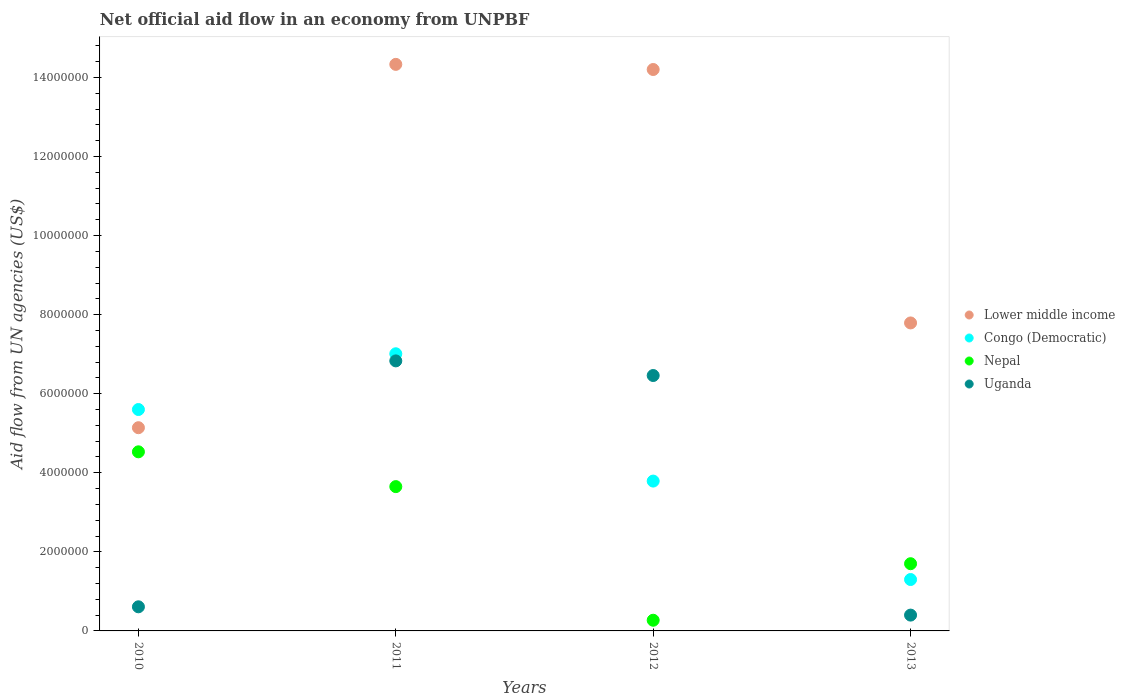Is the number of dotlines equal to the number of legend labels?
Your response must be concise. Yes. What is the net official aid flow in Nepal in 2012?
Provide a succinct answer. 2.70e+05. Across all years, what is the maximum net official aid flow in Congo (Democratic)?
Provide a short and direct response. 7.01e+06. Across all years, what is the minimum net official aid flow in Uganda?
Provide a succinct answer. 4.00e+05. In which year was the net official aid flow in Uganda maximum?
Your response must be concise. 2011. In which year was the net official aid flow in Congo (Democratic) minimum?
Make the answer very short. 2013. What is the total net official aid flow in Nepal in the graph?
Make the answer very short. 1.02e+07. What is the difference between the net official aid flow in Lower middle income in 2012 and that in 2013?
Your response must be concise. 6.41e+06. What is the difference between the net official aid flow in Nepal in 2011 and the net official aid flow in Uganda in 2010?
Offer a very short reply. 3.04e+06. What is the average net official aid flow in Congo (Democratic) per year?
Offer a terse response. 4.42e+06. In the year 2011, what is the difference between the net official aid flow in Congo (Democratic) and net official aid flow in Nepal?
Your answer should be compact. 3.36e+06. What is the ratio of the net official aid flow in Congo (Democratic) in 2010 to that in 2012?
Keep it short and to the point. 1.48. Is the net official aid flow in Lower middle income in 2011 less than that in 2013?
Your answer should be very brief. No. Is the difference between the net official aid flow in Congo (Democratic) in 2010 and 2013 greater than the difference between the net official aid flow in Nepal in 2010 and 2013?
Provide a short and direct response. Yes. What is the difference between the highest and the second highest net official aid flow in Uganda?
Offer a terse response. 3.70e+05. What is the difference between the highest and the lowest net official aid flow in Congo (Democratic)?
Provide a short and direct response. 5.71e+06. Is the net official aid flow in Nepal strictly less than the net official aid flow in Uganda over the years?
Ensure brevity in your answer.  No. How many dotlines are there?
Give a very brief answer. 4. Are the values on the major ticks of Y-axis written in scientific E-notation?
Your answer should be very brief. No. Does the graph contain grids?
Offer a very short reply. No. How are the legend labels stacked?
Make the answer very short. Vertical. What is the title of the graph?
Provide a short and direct response. Net official aid flow in an economy from UNPBF. What is the label or title of the Y-axis?
Ensure brevity in your answer.  Aid flow from UN agencies (US$). What is the Aid flow from UN agencies (US$) of Lower middle income in 2010?
Offer a terse response. 5.14e+06. What is the Aid flow from UN agencies (US$) in Congo (Democratic) in 2010?
Keep it short and to the point. 5.60e+06. What is the Aid flow from UN agencies (US$) in Nepal in 2010?
Your response must be concise. 4.53e+06. What is the Aid flow from UN agencies (US$) of Uganda in 2010?
Provide a short and direct response. 6.10e+05. What is the Aid flow from UN agencies (US$) in Lower middle income in 2011?
Your answer should be very brief. 1.43e+07. What is the Aid flow from UN agencies (US$) in Congo (Democratic) in 2011?
Offer a very short reply. 7.01e+06. What is the Aid flow from UN agencies (US$) in Nepal in 2011?
Ensure brevity in your answer.  3.65e+06. What is the Aid flow from UN agencies (US$) of Uganda in 2011?
Give a very brief answer. 6.83e+06. What is the Aid flow from UN agencies (US$) of Lower middle income in 2012?
Provide a succinct answer. 1.42e+07. What is the Aid flow from UN agencies (US$) in Congo (Democratic) in 2012?
Your answer should be very brief. 3.79e+06. What is the Aid flow from UN agencies (US$) of Uganda in 2012?
Ensure brevity in your answer.  6.46e+06. What is the Aid flow from UN agencies (US$) in Lower middle income in 2013?
Your answer should be very brief. 7.79e+06. What is the Aid flow from UN agencies (US$) of Congo (Democratic) in 2013?
Make the answer very short. 1.30e+06. What is the Aid flow from UN agencies (US$) of Nepal in 2013?
Your response must be concise. 1.70e+06. What is the Aid flow from UN agencies (US$) in Uganda in 2013?
Your answer should be compact. 4.00e+05. Across all years, what is the maximum Aid flow from UN agencies (US$) in Lower middle income?
Provide a short and direct response. 1.43e+07. Across all years, what is the maximum Aid flow from UN agencies (US$) of Congo (Democratic)?
Ensure brevity in your answer.  7.01e+06. Across all years, what is the maximum Aid flow from UN agencies (US$) of Nepal?
Provide a succinct answer. 4.53e+06. Across all years, what is the maximum Aid flow from UN agencies (US$) in Uganda?
Offer a terse response. 6.83e+06. Across all years, what is the minimum Aid flow from UN agencies (US$) of Lower middle income?
Your answer should be very brief. 5.14e+06. Across all years, what is the minimum Aid flow from UN agencies (US$) of Congo (Democratic)?
Your answer should be very brief. 1.30e+06. What is the total Aid flow from UN agencies (US$) in Lower middle income in the graph?
Offer a terse response. 4.15e+07. What is the total Aid flow from UN agencies (US$) of Congo (Democratic) in the graph?
Your answer should be very brief. 1.77e+07. What is the total Aid flow from UN agencies (US$) in Nepal in the graph?
Provide a short and direct response. 1.02e+07. What is the total Aid flow from UN agencies (US$) in Uganda in the graph?
Your answer should be compact. 1.43e+07. What is the difference between the Aid flow from UN agencies (US$) in Lower middle income in 2010 and that in 2011?
Ensure brevity in your answer.  -9.19e+06. What is the difference between the Aid flow from UN agencies (US$) in Congo (Democratic) in 2010 and that in 2011?
Offer a terse response. -1.41e+06. What is the difference between the Aid flow from UN agencies (US$) of Nepal in 2010 and that in 2011?
Ensure brevity in your answer.  8.80e+05. What is the difference between the Aid flow from UN agencies (US$) in Uganda in 2010 and that in 2011?
Offer a very short reply. -6.22e+06. What is the difference between the Aid flow from UN agencies (US$) in Lower middle income in 2010 and that in 2012?
Your response must be concise. -9.06e+06. What is the difference between the Aid flow from UN agencies (US$) of Congo (Democratic) in 2010 and that in 2012?
Your response must be concise. 1.81e+06. What is the difference between the Aid flow from UN agencies (US$) of Nepal in 2010 and that in 2012?
Keep it short and to the point. 4.26e+06. What is the difference between the Aid flow from UN agencies (US$) in Uganda in 2010 and that in 2012?
Make the answer very short. -5.85e+06. What is the difference between the Aid flow from UN agencies (US$) in Lower middle income in 2010 and that in 2013?
Offer a terse response. -2.65e+06. What is the difference between the Aid flow from UN agencies (US$) of Congo (Democratic) in 2010 and that in 2013?
Your answer should be very brief. 4.30e+06. What is the difference between the Aid flow from UN agencies (US$) in Nepal in 2010 and that in 2013?
Offer a terse response. 2.83e+06. What is the difference between the Aid flow from UN agencies (US$) of Lower middle income in 2011 and that in 2012?
Offer a terse response. 1.30e+05. What is the difference between the Aid flow from UN agencies (US$) in Congo (Democratic) in 2011 and that in 2012?
Give a very brief answer. 3.22e+06. What is the difference between the Aid flow from UN agencies (US$) of Nepal in 2011 and that in 2012?
Your answer should be very brief. 3.38e+06. What is the difference between the Aid flow from UN agencies (US$) in Lower middle income in 2011 and that in 2013?
Offer a very short reply. 6.54e+06. What is the difference between the Aid flow from UN agencies (US$) in Congo (Democratic) in 2011 and that in 2013?
Make the answer very short. 5.71e+06. What is the difference between the Aid flow from UN agencies (US$) of Nepal in 2011 and that in 2013?
Provide a short and direct response. 1.95e+06. What is the difference between the Aid flow from UN agencies (US$) in Uganda in 2011 and that in 2013?
Your answer should be very brief. 6.43e+06. What is the difference between the Aid flow from UN agencies (US$) of Lower middle income in 2012 and that in 2013?
Offer a terse response. 6.41e+06. What is the difference between the Aid flow from UN agencies (US$) in Congo (Democratic) in 2012 and that in 2013?
Keep it short and to the point. 2.49e+06. What is the difference between the Aid flow from UN agencies (US$) in Nepal in 2012 and that in 2013?
Offer a very short reply. -1.43e+06. What is the difference between the Aid flow from UN agencies (US$) of Uganda in 2012 and that in 2013?
Your response must be concise. 6.06e+06. What is the difference between the Aid flow from UN agencies (US$) of Lower middle income in 2010 and the Aid flow from UN agencies (US$) of Congo (Democratic) in 2011?
Keep it short and to the point. -1.87e+06. What is the difference between the Aid flow from UN agencies (US$) of Lower middle income in 2010 and the Aid flow from UN agencies (US$) of Nepal in 2011?
Keep it short and to the point. 1.49e+06. What is the difference between the Aid flow from UN agencies (US$) in Lower middle income in 2010 and the Aid flow from UN agencies (US$) in Uganda in 2011?
Your answer should be very brief. -1.69e+06. What is the difference between the Aid flow from UN agencies (US$) of Congo (Democratic) in 2010 and the Aid flow from UN agencies (US$) of Nepal in 2011?
Keep it short and to the point. 1.95e+06. What is the difference between the Aid flow from UN agencies (US$) of Congo (Democratic) in 2010 and the Aid flow from UN agencies (US$) of Uganda in 2011?
Provide a short and direct response. -1.23e+06. What is the difference between the Aid flow from UN agencies (US$) in Nepal in 2010 and the Aid flow from UN agencies (US$) in Uganda in 2011?
Provide a short and direct response. -2.30e+06. What is the difference between the Aid flow from UN agencies (US$) in Lower middle income in 2010 and the Aid flow from UN agencies (US$) in Congo (Democratic) in 2012?
Offer a very short reply. 1.35e+06. What is the difference between the Aid flow from UN agencies (US$) in Lower middle income in 2010 and the Aid flow from UN agencies (US$) in Nepal in 2012?
Provide a short and direct response. 4.87e+06. What is the difference between the Aid flow from UN agencies (US$) of Lower middle income in 2010 and the Aid flow from UN agencies (US$) of Uganda in 2012?
Give a very brief answer. -1.32e+06. What is the difference between the Aid flow from UN agencies (US$) of Congo (Democratic) in 2010 and the Aid flow from UN agencies (US$) of Nepal in 2012?
Ensure brevity in your answer.  5.33e+06. What is the difference between the Aid flow from UN agencies (US$) in Congo (Democratic) in 2010 and the Aid flow from UN agencies (US$) in Uganda in 2012?
Ensure brevity in your answer.  -8.60e+05. What is the difference between the Aid flow from UN agencies (US$) in Nepal in 2010 and the Aid flow from UN agencies (US$) in Uganda in 2012?
Offer a terse response. -1.93e+06. What is the difference between the Aid flow from UN agencies (US$) of Lower middle income in 2010 and the Aid flow from UN agencies (US$) of Congo (Democratic) in 2013?
Your response must be concise. 3.84e+06. What is the difference between the Aid flow from UN agencies (US$) of Lower middle income in 2010 and the Aid flow from UN agencies (US$) of Nepal in 2013?
Provide a succinct answer. 3.44e+06. What is the difference between the Aid flow from UN agencies (US$) in Lower middle income in 2010 and the Aid flow from UN agencies (US$) in Uganda in 2013?
Your answer should be compact. 4.74e+06. What is the difference between the Aid flow from UN agencies (US$) in Congo (Democratic) in 2010 and the Aid flow from UN agencies (US$) in Nepal in 2013?
Offer a terse response. 3.90e+06. What is the difference between the Aid flow from UN agencies (US$) of Congo (Democratic) in 2010 and the Aid flow from UN agencies (US$) of Uganda in 2013?
Offer a very short reply. 5.20e+06. What is the difference between the Aid flow from UN agencies (US$) in Nepal in 2010 and the Aid flow from UN agencies (US$) in Uganda in 2013?
Offer a terse response. 4.13e+06. What is the difference between the Aid flow from UN agencies (US$) of Lower middle income in 2011 and the Aid flow from UN agencies (US$) of Congo (Democratic) in 2012?
Offer a terse response. 1.05e+07. What is the difference between the Aid flow from UN agencies (US$) of Lower middle income in 2011 and the Aid flow from UN agencies (US$) of Nepal in 2012?
Your response must be concise. 1.41e+07. What is the difference between the Aid flow from UN agencies (US$) of Lower middle income in 2011 and the Aid flow from UN agencies (US$) of Uganda in 2012?
Offer a very short reply. 7.87e+06. What is the difference between the Aid flow from UN agencies (US$) in Congo (Democratic) in 2011 and the Aid flow from UN agencies (US$) in Nepal in 2012?
Offer a very short reply. 6.74e+06. What is the difference between the Aid flow from UN agencies (US$) of Congo (Democratic) in 2011 and the Aid flow from UN agencies (US$) of Uganda in 2012?
Ensure brevity in your answer.  5.50e+05. What is the difference between the Aid flow from UN agencies (US$) of Nepal in 2011 and the Aid flow from UN agencies (US$) of Uganda in 2012?
Provide a succinct answer. -2.81e+06. What is the difference between the Aid flow from UN agencies (US$) of Lower middle income in 2011 and the Aid flow from UN agencies (US$) of Congo (Democratic) in 2013?
Ensure brevity in your answer.  1.30e+07. What is the difference between the Aid flow from UN agencies (US$) of Lower middle income in 2011 and the Aid flow from UN agencies (US$) of Nepal in 2013?
Your answer should be compact. 1.26e+07. What is the difference between the Aid flow from UN agencies (US$) of Lower middle income in 2011 and the Aid flow from UN agencies (US$) of Uganda in 2013?
Your response must be concise. 1.39e+07. What is the difference between the Aid flow from UN agencies (US$) in Congo (Democratic) in 2011 and the Aid flow from UN agencies (US$) in Nepal in 2013?
Offer a terse response. 5.31e+06. What is the difference between the Aid flow from UN agencies (US$) in Congo (Democratic) in 2011 and the Aid flow from UN agencies (US$) in Uganda in 2013?
Provide a short and direct response. 6.61e+06. What is the difference between the Aid flow from UN agencies (US$) of Nepal in 2011 and the Aid flow from UN agencies (US$) of Uganda in 2013?
Offer a terse response. 3.25e+06. What is the difference between the Aid flow from UN agencies (US$) in Lower middle income in 2012 and the Aid flow from UN agencies (US$) in Congo (Democratic) in 2013?
Your answer should be compact. 1.29e+07. What is the difference between the Aid flow from UN agencies (US$) of Lower middle income in 2012 and the Aid flow from UN agencies (US$) of Nepal in 2013?
Your answer should be compact. 1.25e+07. What is the difference between the Aid flow from UN agencies (US$) in Lower middle income in 2012 and the Aid flow from UN agencies (US$) in Uganda in 2013?
Offer a terse response. 1.38e+07. What is the difference between the Aid flow from UN agencies (US$) of Congo (Democratic) in 2012 and the Aid flow from UN agencies (US$) of Nepal in 2013?
Provide a short and direct response. 2.09e+06. What is the difference between the Aid flow from UN agencies (US$) in Congo (Democratic) in 2012 and the Aid flow from UN agencies (US$) in Uganda in 2013?
Provide a short and direct response. 3.39e+06. What is the difference between the Aid flow from UN agencies (US$) in Nepal in 2012 and the Aid flow from UN agencies (US$) in Uganda in 2013?
Provide a short and direct response. -1.30e+05. What is the average Aid flow from UN agencies (US$) of Lower middle income per year?
Offer a very short reply. 1.04e+07. What is the average Aid flow from UN agencies (US$) in Congo (Democratic) per year?
Offer a terse response. 4.42e+06. What is the average Aid flow from UN agencies (US$) of Nepal per year?
Your answer should be compact. 2.54e+06. What is the average Aid flow from UN agencies (US$) in Uganda per year?
Offer a very short reply. 3.58e+06. In the year 2010, what is the difference between the Aid flow from UN agencies (US$) of Lower middle income and Aid flow from UN agencies (US$) of Congo (Democratic)?
Offer a terse response. -4.60e+05. In the year 2010, what is the difference between the Aid flow from UN agencies (US$) of Lower middle income and Aid flow from UN agencies (US$) of Uganda?
Make the answer very short. 4.53e+06. In the year 2010, what is the difference between the Aid flow from UN agencies (US$) of Congo (Democratic) and Aid flow from UN agencies (US$) of Nepal?
Offer a terse response. 1.07e+06. In the year 2010, what is the difference between the Aid flow from UN agencies (US$) of Congo (Democratic) and Aid flow from UN agencies (US$) of Uganda?
Your response must be concise. 4.99e+06. In the year 2010, what is the difference between the Aid flow from UN agencies (US$) in Nepal and Aid flow from UN agencies (US$) in Uganda?
Give a very brief answer. 3.92e+06. In the year 2011, what is the difference between the Aid flow from UN agencies (US$) of Lower middle income and Aid flow from UN agencies (US$) of Congo (Democratic)?
Your answer should be very brief. 7.32e+06. In the year 2011, what is the difference between the Aid flow from UN agencies (US$) of Lower middle income and Aid flow from UN agencies (US$) of Nepal?
Provide a succinct answer. 1.07e+07. In the year 2011, what is the difference between the Aid flow from UN agencies (US$) of Lower middle income and Aid flow from UN agencies (US$) of Uganda?
Make the answer very short. 7.50e+06. In the year 2011, what is the difference between the Aid flow from UN agencies (US$) of Congo (Democratic) and Aid flow from UN agencies (US$) of Nepal?
Ensure brevity in your answer.  3.36e+06. In the year 2011, what is the difference between the Aid flow from UN agencies (US$) in Nepal and Aid flow from UN agencies (US$) in Uganda?
Your response must be concise. -3.18e+06. In the year 2012, what is the difference between the Aid flow from UN agencies (US$) of Lower middle income and Aid flow from UN agencies (US$) of Congo (Democratic)?
Offer a very short reply. 1.04e+07. In the year 2012, what is the difference between the Aid flow from UN agencies (US$) of Lower middle income and Aid flow from UN agencies (US$) of Nepal?
Ensure brevity in your answer.  1.39e+07. In the year 2012, what is the difference between the Aid flow from UN agencies (US$) of Lower middle income and Aid flow from UN agencies (US$) of Uganda?
Your answer should be compact. 7.74e+06. In the year 2012, what is the difference between the Aid flow from UN agencies (US$) in Congo (Democratic) and Aid flow from UN agencies (US$) in Nepal?
Your response must be concise. 3.52e+06. In the year 2012, what is the difference between the Aid flow from UN agencies (US$) in Congo (Democratic) and Aid flow from UN agencies (US$) in Uganda?
Your response must be concise. -2.67e+06. In the year 2012, what is the difference between the Aid flow from UN agencies (US$) in Nepal and Aid flow from UN agencies (US$) in Uganda?
Keep it short and to the point. -6.19e+06. In the year 2013, what is the difference between the Aid flow from UN agencies (US$) of Lower middle income and Aid flow from UN agencies (US$) of Congo (Democratic)?
Your answer should be very brief. 6.49e+06. In the year 2013, what is the difference between the Aid flow from UN agencies (US$) in Lower middle income and Aid flow from UN agencies (US$) in Nepal?
Give a very brief answer. 6.09e+06. In the year 2013, what is the difference between the Aid flow from UN agencies (US$) of Lower middle income and Aid flow from UN agencies (US$) of Uganda?
Keep it short and to the point. 7.39e+06. In the year 2013, what is the difference between the Aid flow from UN agencies (US$) in Congo (Democratic) and Aid flow from UN agencies (US$) in Nepal?
Your response must be concise. -4.00e+05. In the year 2013, what is the difference between the Aid flow from UN agencies (US$) in Congo (Democratic) and Aid flow from UN agencies (US$) in Uganda?
Make the answer very short. 9.00e+05. In the year 2013, what is the difference between the Aid flow from UN agencies (US$) in Nepal and Aid flow from UN agencies (US$) in Uganda?
Provide a succinct answer. 1.30e+06. What is the ratio of the Aid flow from UN agencies (US$) of Lower middle income in 2010 to that in 2011?
Offer a terse response. 0.36. What is the ratio of the Aid flow from UN agencies (US$) of Congo (Democratic) in 2010 to that in 2011?
Keep it short and to the point. 0.8. What is the ratio of the Aid flow from UN agencies (US$) in Nepal in 2010 to that in 2011?
Give a very brief answer. 1.24. What is the ratio of the Aid flow from UN agencies (US$) in Uganda in 2010 to that in 2011?
Offer a terse response. 0.09. What is the ratio of the Aid flow from UN agencies (US$) in Lower middle income in 2010 to that in 2012?
Keep it short and to the point. 0.36. What is the ratio of the Aid flow from UN agencies (US$) of Congo (Democratic) in 2010 to that in 2012?
Provide a succinct answer. 1.48. What is the ratio of the Aid flow from UN agencies (US$) in Nepal in 2010 to that in 2012?
Ensure brevity in your answer.  16.78. What is the ratio of the Aid flow from UN agencies (US$) in Uganda in 2010 to that in 2012?
Provide a succinct answer. 0.09. What is the ratio of the Aid flow from UN agencies (US$) in Lower middle income in 2010 to that in 2013?
Provide a succinct answer. 0.66. What is the ratio of the Aid flow from UN agencies (US$) in Congo (Democratic) in 2010 to that in 2013?
Provide a short and direct response. 4.31. What is the ratio of the Aid flow from UN agencies (US$) of Nepal in 2010 to that in 2013?
Give a very brief answer. 2.66. What is the ratio of the Aid flow from UN agencies (US$) of Uganda in 2010 to that in 2013?
Your answer should be compact. 1.52. What is the ratio of the Aid flow from UN agencies (US$) in Lower middle income in 2011 to that in 2012?
Keep it short and to the point. 1.01. What is the ratio of the Aid flow from UN agencies (US$) of Congo (Democratic) in 2011 to that in 2012?
Provide a short and direct response. 1.85. What is the ratio of the Aid flow from UN agencies (US$) in Nepal in 2011 to that in 2012?
Provide a succinct answer. 13.52. What is the ratio of the Aid flow from UN agencies (US$) of Uganda in 2011 to that in 2012?
Provide a short and direct response. 1.06. What is the ratio of the Aid flow from UN agencies (US$) in Lower middle income in 2011 to that in 2013?
Offer a terse response. 1.84. What is the ratio of the Aid flow from UN agencies (US$) in Congo (Democratic) in 2011 to that in 2013?
Make the answer very short. 5.39. What is the ratio of the Aid flow from UN agencies (US$) of Nepal in 2011 to that in 2013?
Your answer should be compact. 2.15. What is the ratio of the Aid flow from UN agencies (US$) in Uganda in 2011 to that in 2013?
Your response must be concise. 17.07. What is the ratio of the Aid flow from UN agencies (US$) in Lower middle income in 2012 to that in 2013?
Keep it short and to the point. 1.82. What is the ratio of the Aid flow from UN agencies (US$) in Congo (Democratic) in 2012 to that in 2013?
Provide a short and direct response. 2.92. What is the ratio of the Aid flow from UN agencies (US$) in Nepal in 2012 to that in 2013?
Give a very brief answer. 0.16. What is the ratio of the Aid flow from UN agencies (US$) in Uganda in 2012 to that in 2013?
Keep it short and to the point. 16.15. What is the difference between the highest and the second highest Aid flow from UN agencies (US$) of Lower middle income?
Your answer should be very brief. 1.30e+05. What is the difference between the highest and the second highest Aid flow from UN agencies (US$) in Congo (Democratic)?
Keep it short and to the point. 1.41e+06. What is the difference between the highest and the second highest Aid flow from UN agencies (US$) of Nepal?
Your answer should be very brief. 8.80e+05. What is the difference between the highest and the lowest Aid flow from UN agencies (US$) of Lower middle income?
Keep it short and to the point. 9.19e+06. What is the difference between the highest and the lowest Aid flow from UN agencies (US$) of Congo (Democratic)?
Your answer should be very brief. 5.71e+06. What is the difference between the highest and the lowest Aid flow from UN agencies (US$) of Nepal?
Offer a very short reply. 4.26e+06. What is the difference between the highest and the lowest Aid flow from UN agencies (US$) of Uganda?
Your answer should be compact. 6.43e+06. 